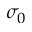Convert formula to latex. <formula><loc_0><loc_0><loc_500><loc_500>\sigma _ { 0 }</formula> 